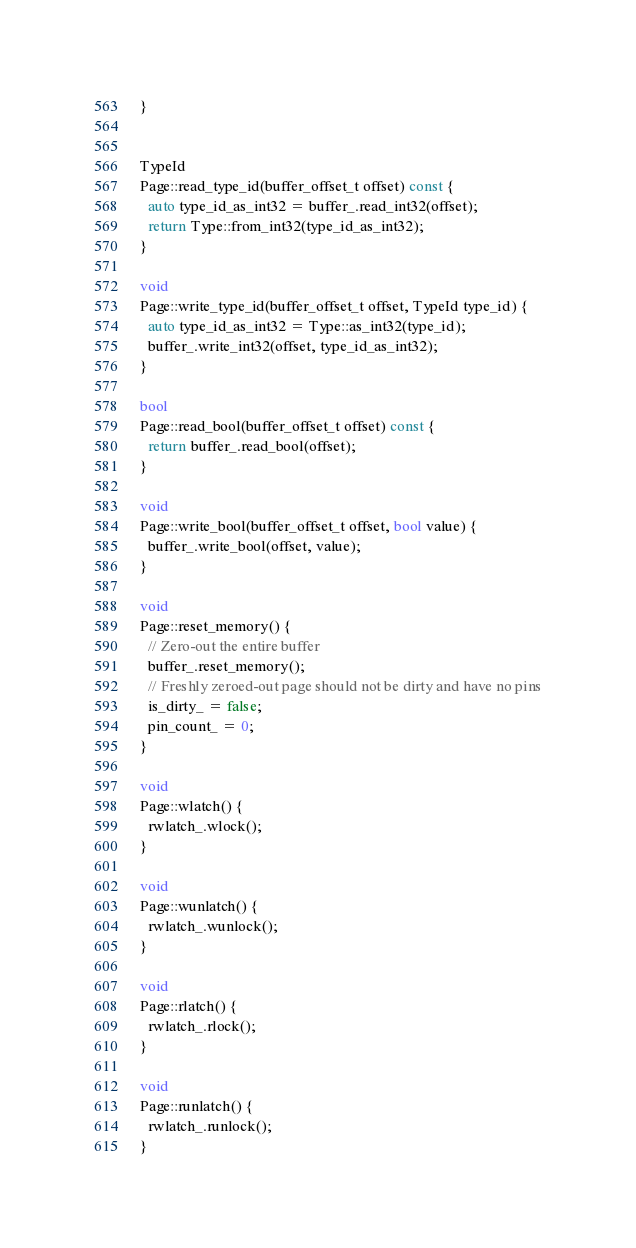<code> <loc_0><loc_0><loc_500><loc_500><_C++_>}


TypeId
Page::read_type_id(buffer_offset_t offset) const {
  auto type_id_as_int32 = buffer_.read_int32(offset);
  return Type::from_int32(type_id_as_int32);
}

void
Page::write_type_id(buffer_offset_t offset, TypeId type_id) {
  auto type_id_as_int32 = Type::as_int32(type_id);
  buffer_.write_int32(offset, type_id_as_int32);
}

bool
Page::read_bool(buffer_offset_t offset) const {
  return buffer_.read_bool(offset);
}

void
Page::write_bool(buffer_offset_t offset, bool value) {
  buffer_.write_bool(offset, value);
}

void
Page::reset_memory() {
  // Zero-out the entire buffer
  buffer_.reset_memory();
  // Freshly zeroed-out page should not be dirty and have no pins
  is_dirty_ = false;
  pin_count_ = 0;
}

void
Page::wlatch() {
  rwlatch_.wlock();
}

void
Page::wunlatch() {
  rwlatch_.wunlock();
}

void
Page::rlatch() {
  rwlatch_.rlock();
}

void
Page::runlatch() {
  rwlatch_.runlock();
}
</code> 